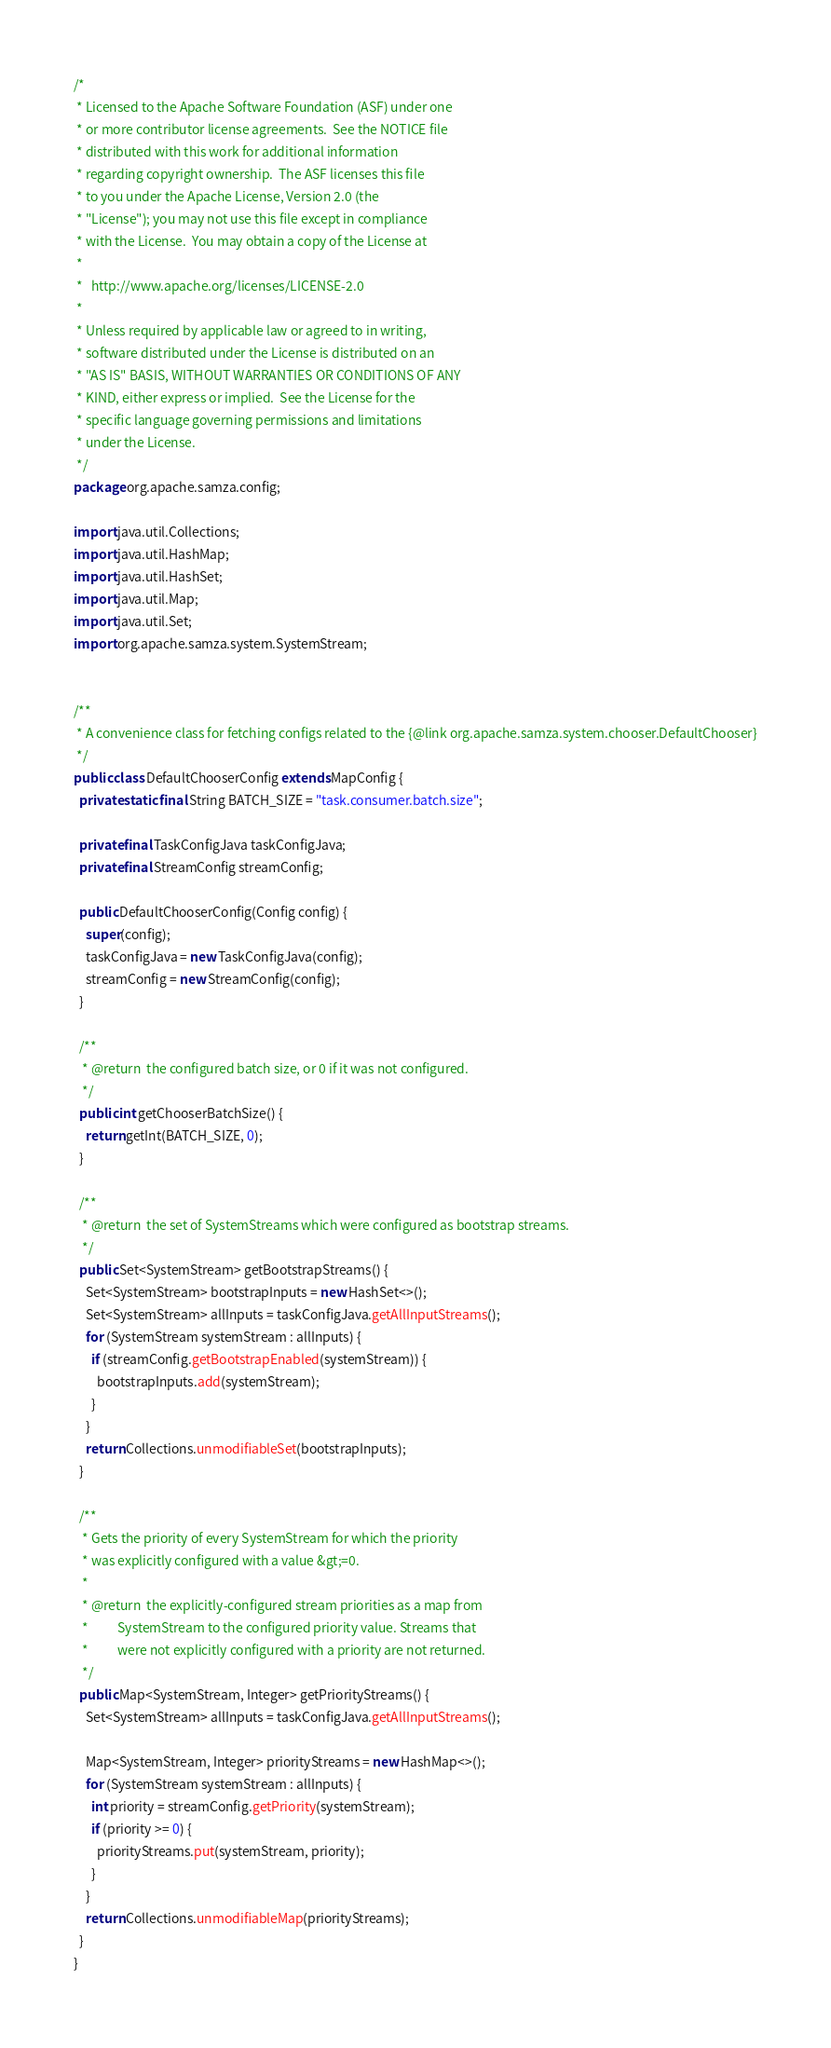<code> <loc_0><loc_0><loc_500><loc_500><_Java_>/*
 * Licensed to the Apache Software Foundation (ASF) under one
 * or more contributor license agreements.  See the NOTICE file
 * distributed with this work for additional information
 * regarding copyright ownership.  The ASF licenses this file
 * to you under the Apache License, Version 2.0 (the
 * "License"); you may not use this file except in compliance
 * with the License.  You may obtain a copy of the License at
 *
 *   http://www.apache.org/licenses/LICENSE-2.0
 *
 * Unless required by applicable law or agreed to in writing,
 * software distributed under the License is distributed on an
 * "AS IS" BASIS, WITHOUT WARRANTIES OR CONDITIONS OF ANY
 * KIND, either express or implied.  See the License for the
 * specific language governing permissions and limitations
 * under the License.
 */
package org.apache.samza.config;

import java.util.Collections;
import java.util.HashMap;
import java.util.HashSet;
import java.util.Map;
import java.util.Set;
import org.apache.samza.system.SystemStream;


/**
 * A convenience class for fetching configs related to the {@link org.apache.samza.system.chooser.DefaultChooser}
 */
public class DefaultChooserConfig extends MapConfig {
  private static final String BATCH_SIZE = "task.consumer.batch.size";

  private final TaskConfigJava taskConfigJava;
  private final StreamConfig streamConfig;

  public DefaultChooserConfig(Config config) {
    super(config);
    taskConfigJava = new TaskConfigJava(config);
    streamConfig = new StreamConfig(config);
  }

  /**
   * @return  the configured batch size, or 0 if it was not configured.
   */
  public int getChooserBatchSize() {
    return getInt(BATCH_SIZE, 0);
  }

  /**
   * @return  the set of SystemStreams which were configured as bootstrap streams.
   */
  public Set<SystemStream> getBootstrapStreams() {
    Set<SystemStream> bootstrapInputs = new HashSet<>();
    Set<SystemStream> allInputs = taskConfigJava.getAllInputStreams();
    for (SystemStream systemStream : allInputs) {
      if (streamConfig.getBootstrapEnabled(systemStream)) {
        bootstrapInputs.add(systemStream);
      }
    }
    return Collections.unmodifiableSet(bootstrapInputs);
  }

  /**
   * Gets the priority of every SystemStream for which the priority
   * was explicitly configured with a value &gt;=0.
   *
   * @return  the explicitly-configured stream priorities as a map from
   *          SystemStream to the configured priority value. Streams that
   *          were not explicitly configured with a priority are not returned.
   */
  public Map<SystemStream, Integer> getPriorityStreams() {
    Set<SystemStream> allInputs = taskConfigJava.getAllInputStreams();

    Map<SystemStream, Integer> priorityStreams = new HashMap<>();
    for (SystemStream systemStream : allInputs) {
      int priority = streamConfig.getPriority(systemStream);
      if (priority >= 0) {
        priorityStreams.put(systemStream, priority);
      }
    }
    return Collections.unmodifiableMap(priorityStreams);
  }
}
</code> 